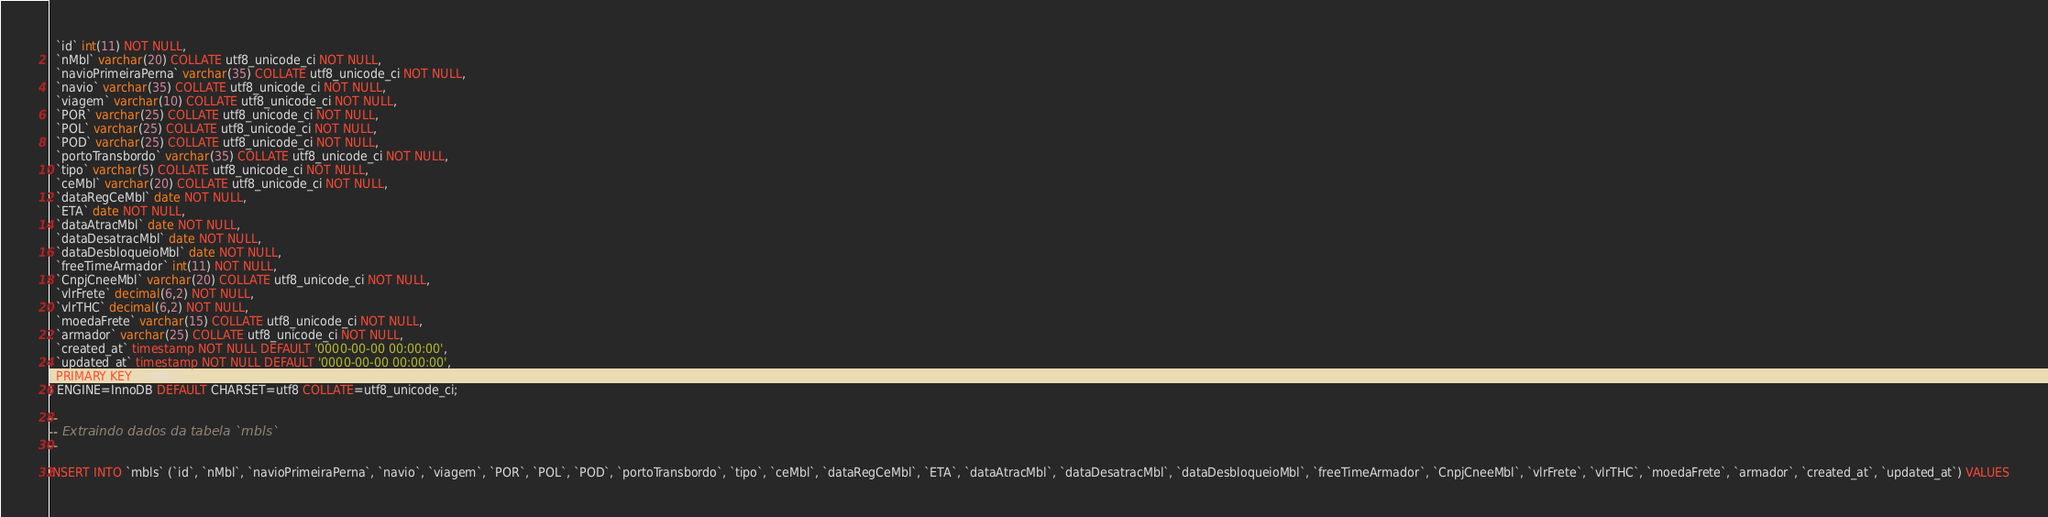Convert code to text. <code><loc_0><loc_0><loc_500><loc_500><_SQL_>  `id` int(11) NOT NULL,
  `nMbl` varchar(20) COLLATE utf8_unicode_ci NOT NULL,
  `navioPrimeiraPerna` varchar(35) COLLATE utf8_unicode_ci NOT NULL,
  `navio` varchar(35) COLLATE utf8_unicode_ci NOT NULL,
  `viagem` varchar(10) COLLATE utf8_unicode_ci NOT NULL,
  `POR` varchar(25) COLLATE utf8_unicode_ci NOT NULL,
  `POL` varchar(25) COLLATE utf8_unicode_ci NOT NULL,
  `POD` varchar(25) COLLATE utf8_unicode_ci NOT NULL,
  `portoTransbordo` varchar(35) COLLATE utf8_unicode_ci NOT NULL,
  `tipo` varchar(5) COLLATE utf8_unicode_ci NOT NULL,
  `ceMbl` varchar(20) COLLATE utf8_unicode_ci NOT NULL,
  `dataRegCeMbl` date NOT NULL,
  `ETA` date NOT NULL,
  `dataAtracMbl` date NOT NULL,
  `dataDesatracMbl` date NOT NULL,
  `dataDesbloqueioMbl` date NOT NULL,
  `freeTimeArmador` int(11) NOT NULL,
  `CnpjCneeMbl` varchar(20) COLLATE utf8_unicode_ci NOT NULL,
  `vlrFrete` decimal(6,2) NOT NULL,
  `vlrTHC` decimal(6,2) NOT NULL,
  `moedaFrete` varchar(15) COLLATE utf8_unicode_ci NOT NULL,
  `armador` varchar(25) COLLATE utf8_unicode_ci NOT NULL,
  `created_at` timestamp NOT NULL DEFAULT '0000-00-00 00:00:00',
  `updated_at` timestamp NOT NULL DEFAULT '0000-00-00 00:00:00',
  PRIMARY KEY (`nMbl`)
) ENGINE=InnoDB DEFAULT CHARSET=utf8 COLLATE=utf8_unicode_ci;

--
-- Extraindo dados da tabela `mbls`
--

INSERT INTO `mbls` (`id`, `nMbl`, `navioPrimeiraPerna`, `navio`, `viagem`, `POR`, `POL`, `POD`, `portoTransbordo`, `tipo`, `ceMbl`, `dataRegCeMbl`, `ETA`, `dataAtracMbl`, `dataDesatracMbl`, `dataDesbloqueioMbl`, `freeTimeArmador`, `CnpjCneeMbl`, `vlrFrete`, `vlrTHC`, `moedaFrete`, `armador`, `created_at`, `updated_at`) VALUES</code> 